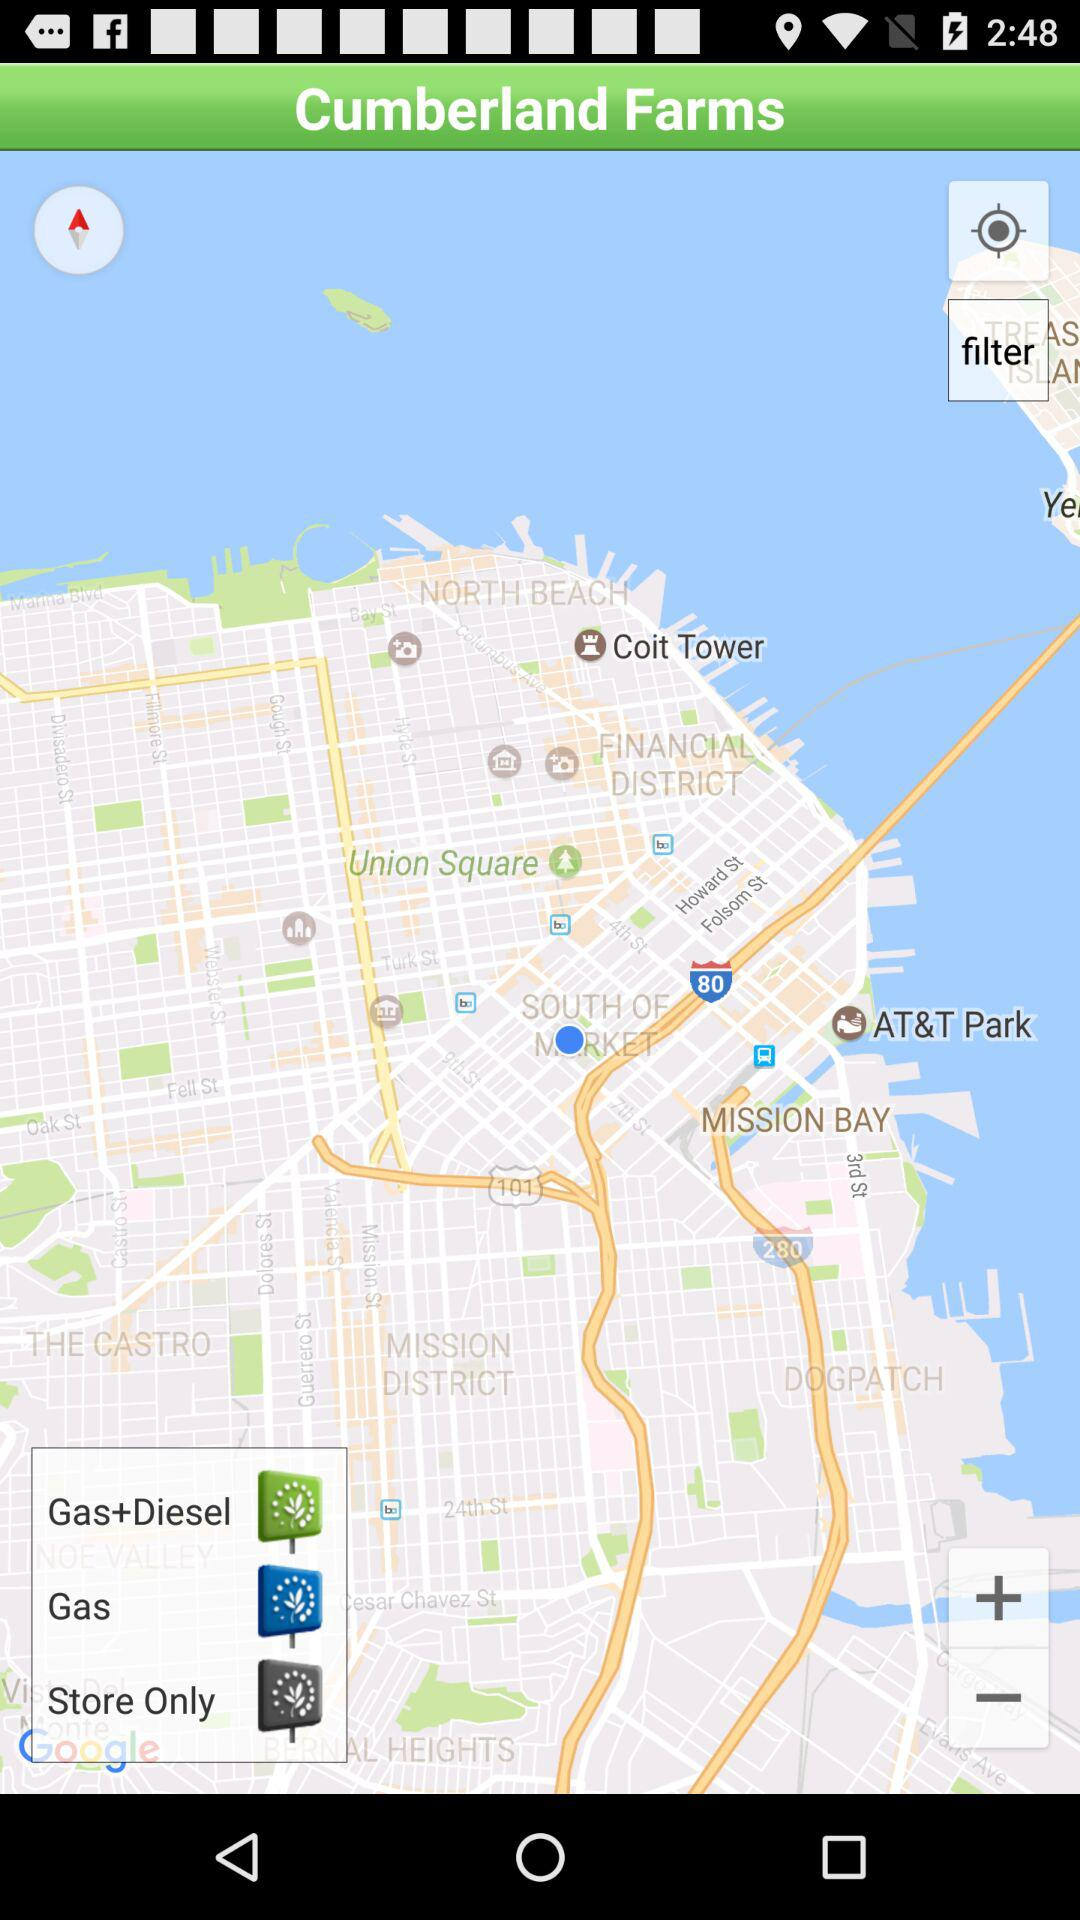Is Cumberland Farms' longitude east or west of GMT?
When the provided information is insufficient, respond with <no answer>. <no answer> 